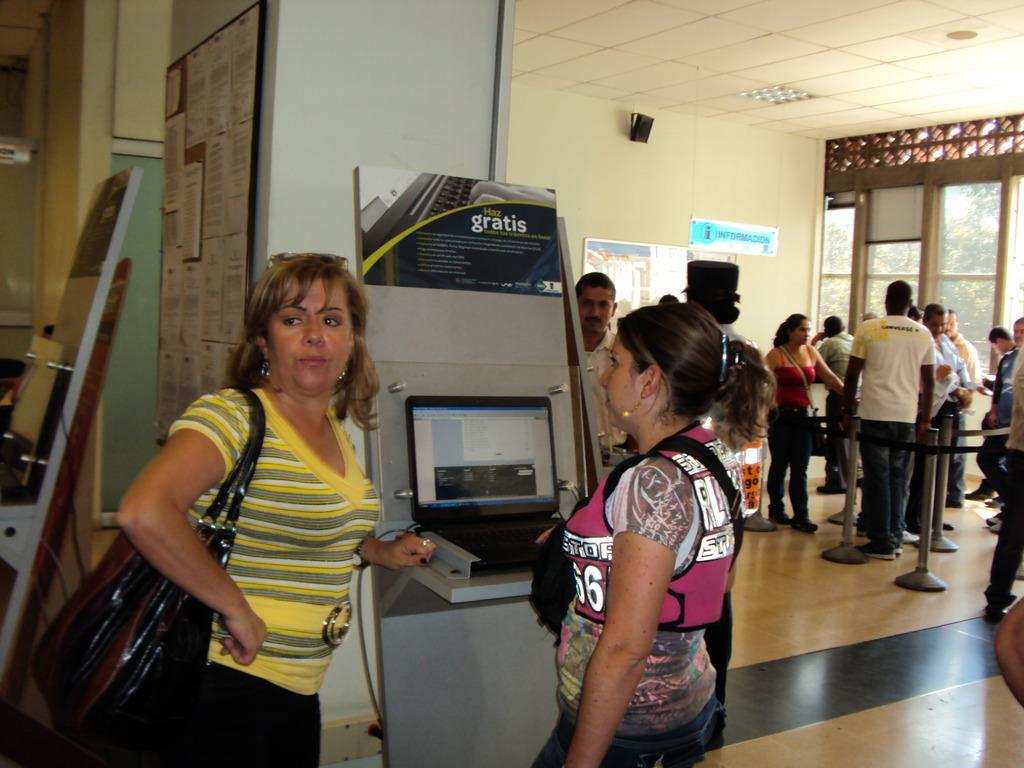Provide a one-sentence caption for the provided image. Two women stand by a booth that says Haz gratis. 